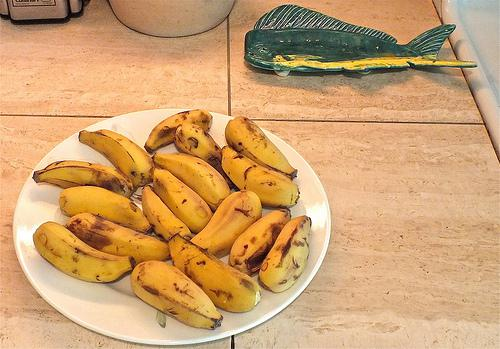Question: what color is the plate?
Choices:
A. Blue.
B. White.
C. Green.
D. Yellow.
Answer with the letter. Answer: B Question: how many bananas are there?
Choices:
A. 17.
B. 18.
C. 19.
D. 20.
Answer with the letter. Answer: A Question: where are the bananas?
Choices:
A. Trees.
B. Counter.
C. Table.
D. On plate.
Answer with the letter. Answer: D Question: how many fish figures are seen?
Choices:
A. One.
B. Two.
C. Four.
D. None.
Answer with the letter. Answer: A Question: what color is the counter?
Choices:
A. Green.
B. Tan.
C. Yellow.
D. Black.
Answer with the letter. Answer: B 